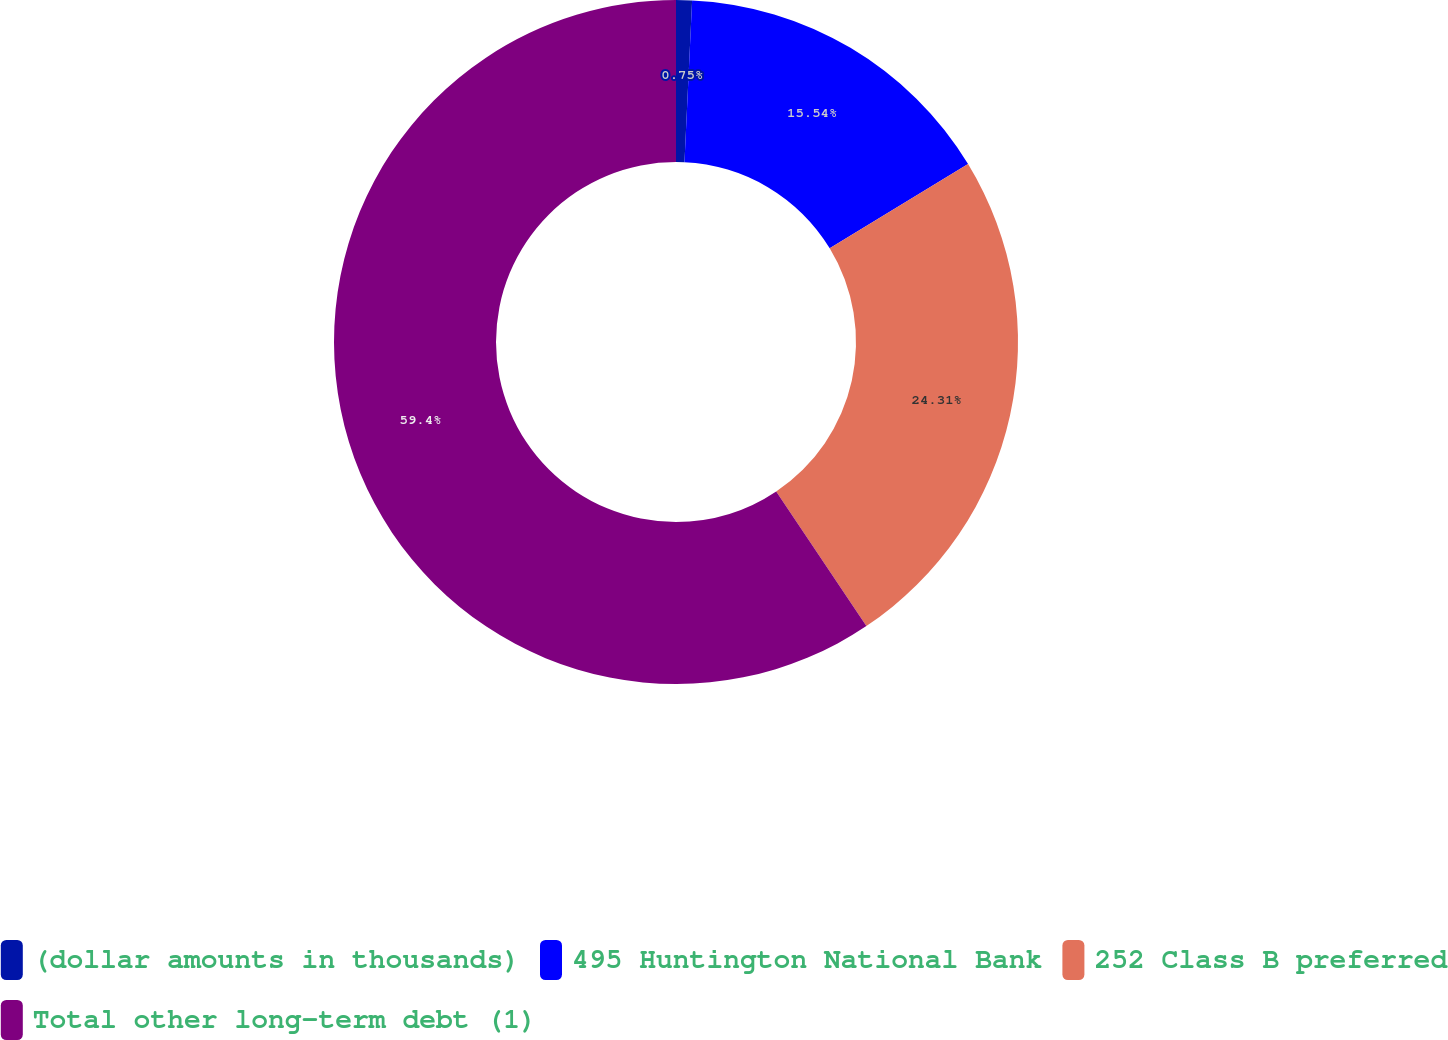Convert chart. <chart><loc_0><loc_0><loc_500><loc_500><pie_chart><fcel>(dollar amounts in thousands)<fcel>495 Huntington National Bank<fcel>252 Class B preferred<fcel>Total other long-term debt (1)<nl><fcel>0.75%<fcel>15.54%<fcel>24.31%<fcel>59.39%<nl></chart> 